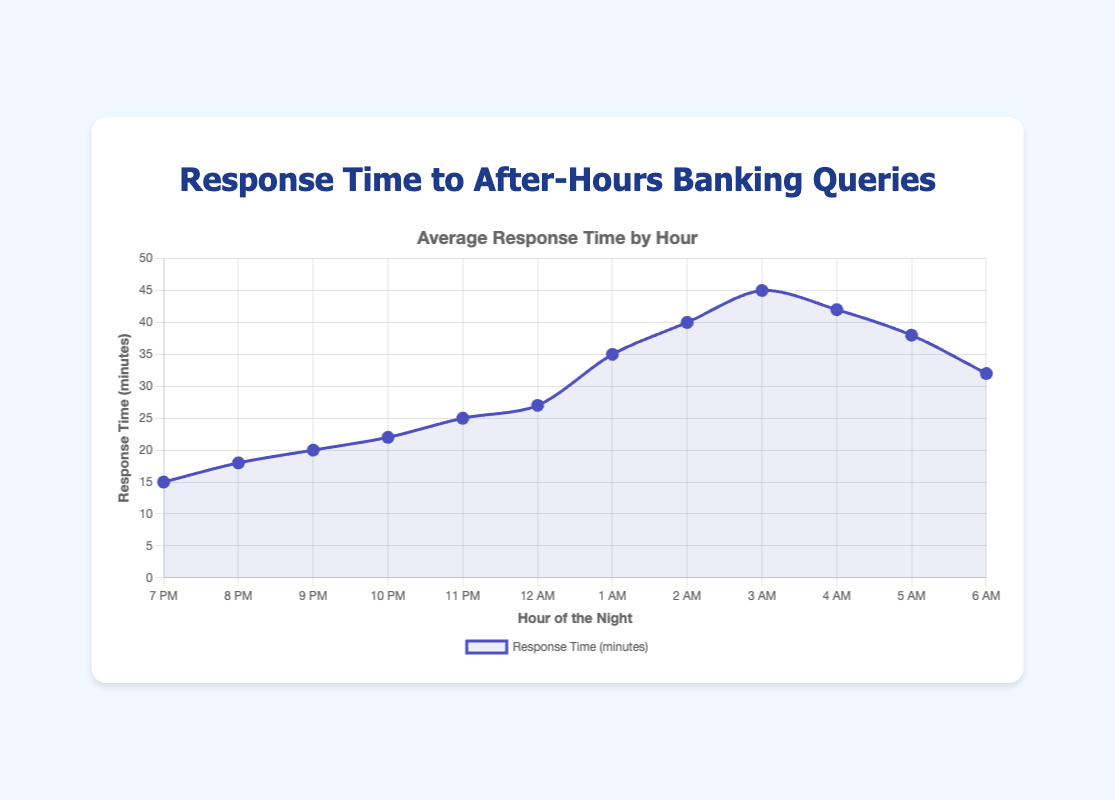What is the response time at 3 AM? Observe the data point corresponding to 3 AM on the x-axis. The y-axis value for this point is 45 minutes.
Answer: 45 minutes During which hour is the response time highest? Look for the data point with the highest y-axis value. The point at 3 AM has the highest response time of 45 minutes.
Answer: 3 AM How does the response time at 7 PM compare to the response time at 12 AM? Examine the data points for 7 PM and 12 AM. The response time at 7 PM is 15 minutes, and at 12 AM it is 27 minutes. 27 is greater than 15.
Answer: The response time at 12 AM is higher What is the average response time from 7 PM to 12 AM? Sum the response times from 7 PM to 12 AM, which are 15, 18, 20, 22, 25, and 27. The total is 127. Divide by the number of hours (127 / 6).
Answer: 21.17 minutes By how many minutes does the response time increase from 8 PM to 1 AM? Determine the response time at 8 PM (18 minutes) and at 1 AM (35 minutes). Calculate the difference (35 - 18).
Answer: 17 minutes During which hours is the response time equal to or greater than 40 minutes? Check the data points where the y-axis value is 40 minutes or more. This occurs at 2 AM (40 minutes) and 3 AM (45 minutes).
Answer: 2 AM and 3 AM Is the response time at 5 AM higher or lower than at 2 AM? Compare the response time at 5 AM (38 minutes) with 2 AM (40 minutes). 38 is lower than 40.
Answer: Lower By what percentage does the response time decrease from 3 AM to 6 AM? The response time at 3 AM is 45 minutes, and at 6 AM it is 32 minutes. The decrease is 45 - 32 = 13 minutes. Calculate the percentage decrease (13/45 * 100).
Answer: Approximately 28.89% What's the median response time from 7 PM to 6 AM? List the response times in order: 15, 18, 20, 22, 25, 27, 32, 35, 38, 40, 42, 45. The median is the average of the 6th and 7th values ((27 + 32) / 2).
Answer: 29.5 minutes Identify two consecutive hours where the response time decreases. Identify hours where the response time decreases from one hour to the next. From 3 AM to 4 AM (45 to 42 minutes) and from 4 AM to 5 AM (42 to 38 minutes). Pick one.
Answer: From 3 AM to 4 AM 